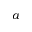Convert formula to latex. <formula><loc_0><loc_0><loc_500><loc_500>a</formula> 